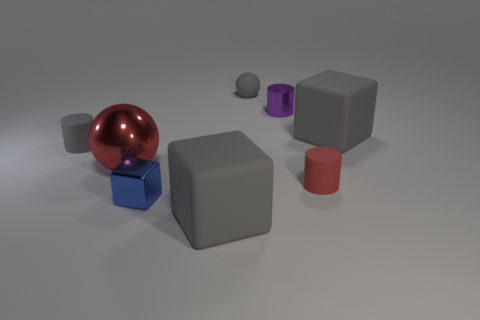Subtract all matte cylinders. How many cylinders are left? 1 Add 2 small rubber objects. How many objects exist? 10 Subtract all cyan balls. How many gray cubes are left? 2 Subtract all cylinders. How many objects are left? 5 Subtract 1 red cylinders. How many objects are left? 7 Subtract all large red balls. Subtract all metallic spheres. How many objects are left? 6 Add 2 red rubber objects. How many red rubber objects are left? 3 Add 3 rubber balls. How many rubber balls exist? 4 